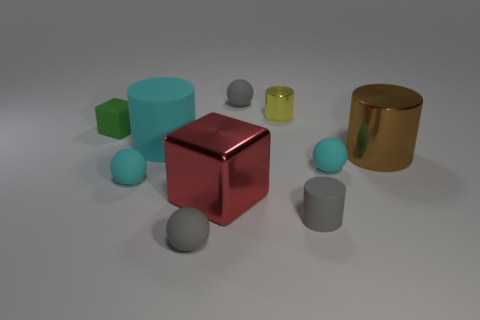Subtract 2 balls. How many balls are left? 2 Subtract all brown balls. Subtract all green cylinders. How many balls are left? 4 Subtract all cylinders. How many objects are left? 6 Subtract all brown shiny balls. Subtract all tiny gray rubber spheres. How many objects are left? 8 Add 8 big cyan rubber things. How many big cyan rubber things are left? 9 Add 6 gray matte cylinders. How many gray matte cylinders exist? 7 Subtract 0 yellow spheres. How many objects are left? 10 